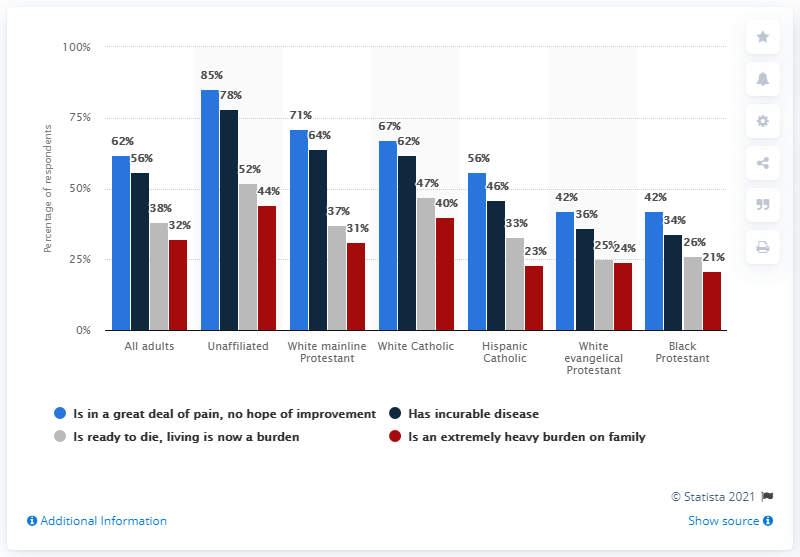Identify some key points in this picture. The percentages listed (67%, 62%, 47%, 40%) do not provide enough information to determine the category of the data set. To determine the category, we would need to know the context in which these percentages were obtained and what they represent. For example, if these percentages represent the religious affiliation of a group of individuals, then the category could be "White Catholic". However, without this context, it is not possible to determine the category of the data set. According to the data provided, the average age of Black Protestants is 30.75. 